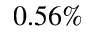Convert formula to latex. <formula><loc_0><loc_0><loc_500><loc_500>0 . 5 6 \%</formula> 